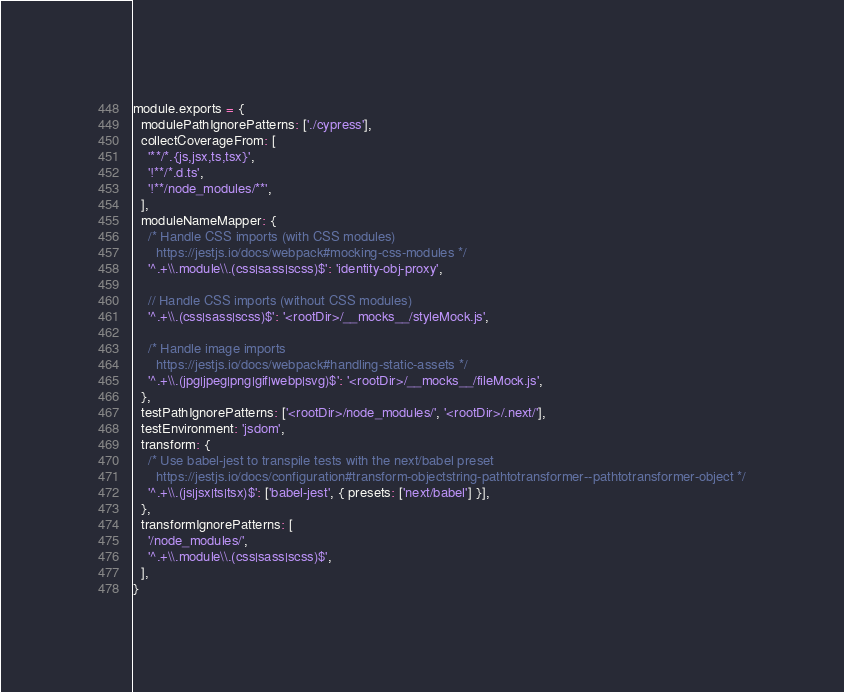Convert code to text. <code><loc_0><loc_0><loc_500><loc_500><_JavaScript_>module.exports = {
  modulePathIgnorePatterns: ['./cypress'],
  collectCoverageFrom: [
    '**/*.{js,jsx,ts,tsx}',
    '!**/*.d.ts',
    '!**/node_modules/**',
  ],
  moduleNameMapper: {
    /* Handle CSS imports (with CSS modules)
      https://jestjs.io/docs/webpack#mocking-css-modules */
    '^.+\\.module\\.(css|sass|scss)$': 'identity-obj-proxy',

    // Handle CSS imports (without CSS modules)
    '^.+\\.(css|sass|scss)$': '<rootDir>/__mocks__/styleMock.js',

    /* Handle image imports
      https://jestjs.io/docs/webpack#handling-static-assets */
    '^.+\\.(jpg|jpeg|png|gif|webp|svg)$': '<rootDir>/__mocks__/fileMock.js',
  },
  testPathIgnorePatterns: ['<rootDir>/node_modules/', '<rootDir>/.next/'],
  testEnvironment: 'jsdom',
  transform: {
    /* Use babel-jest to transpile tests with the next/babel preset
      https://jestjs.io/docs/configuration#transform-objectstring-pathtotransformer--pathtotransformer-object */
    '^.+\\.(js|jsx|ts|tsx)$': ['babel-jest', { presets: ['next/babel'] }],
  },
  transformIgnorePatterns: [
    '/node_modules/',
    '^.+\\.module\\.(css|sass|scss)$',
  ],
}
</code> 